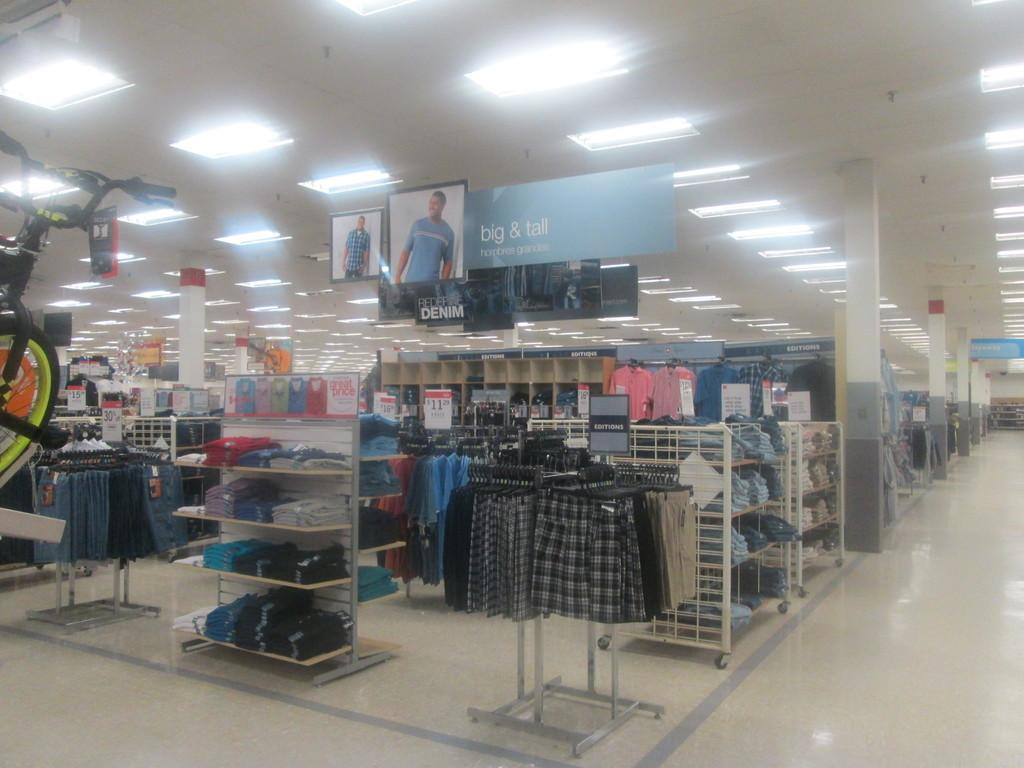<image>
Provide a brief description of the given image. the inside of a store with a banner that says 'big & tall' 